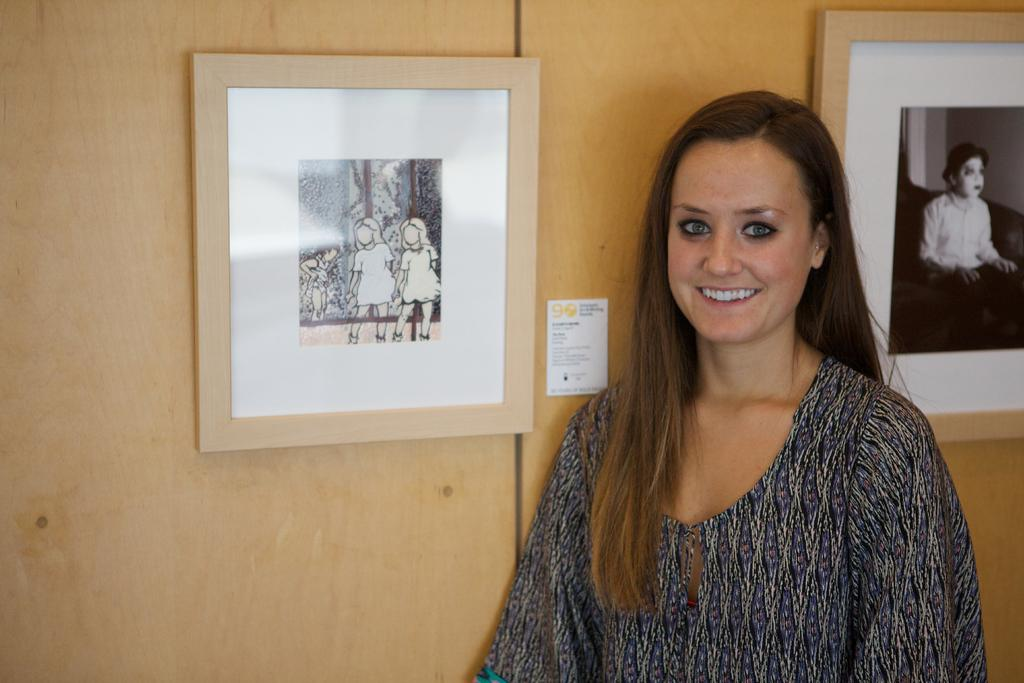Who is present in the image? There is a lady in the image. What can be seen on the wall in the image? There are two photos on the wall and an object on the wall. What type of error can be seen in the lady's vein in the image? There is no mention of the lady's veins or any errors in the image. 